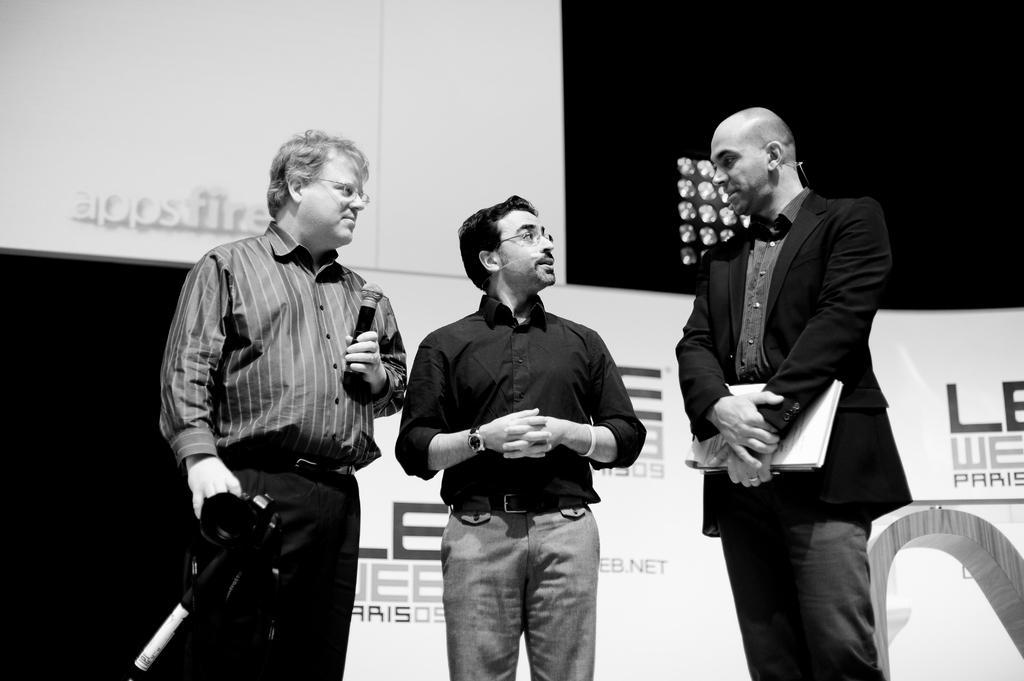How would you summarize this image in a sentence or two? In this picture we can see two people standing and holding objects in their hands. We can see a man wearing a spectacle and standing. There is the text on the boards. We can see the lights in the background. 